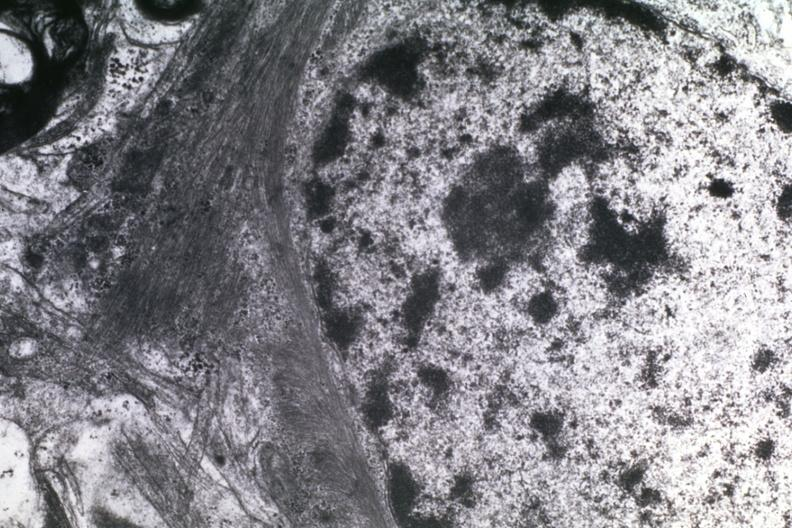what is present?
Answer the question using a single word or phrase. Glioblastoma multiforme 